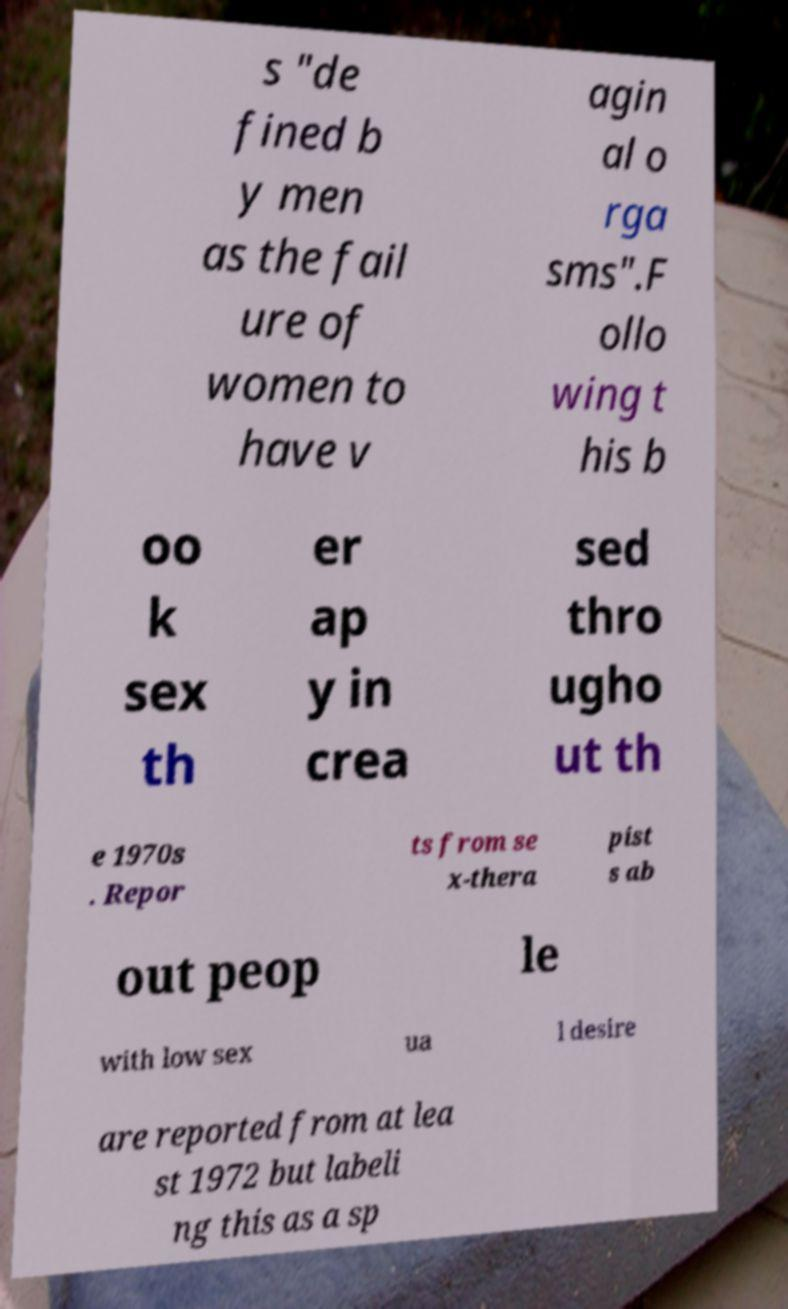There's text embedded in this image that I need extracted. Can you transcribe it verbatim? s "de fined b y men as the fail ure of women to have v agin al o rga sms".F ollo wing t his b oo k sex th er ap y in crea sed thro ugho ut th e 1970s . Repor ts from se x-thera pist s ab out peop le with low sex ua l desire are reported from at lea st 1972 but labeli ng this as a sp 